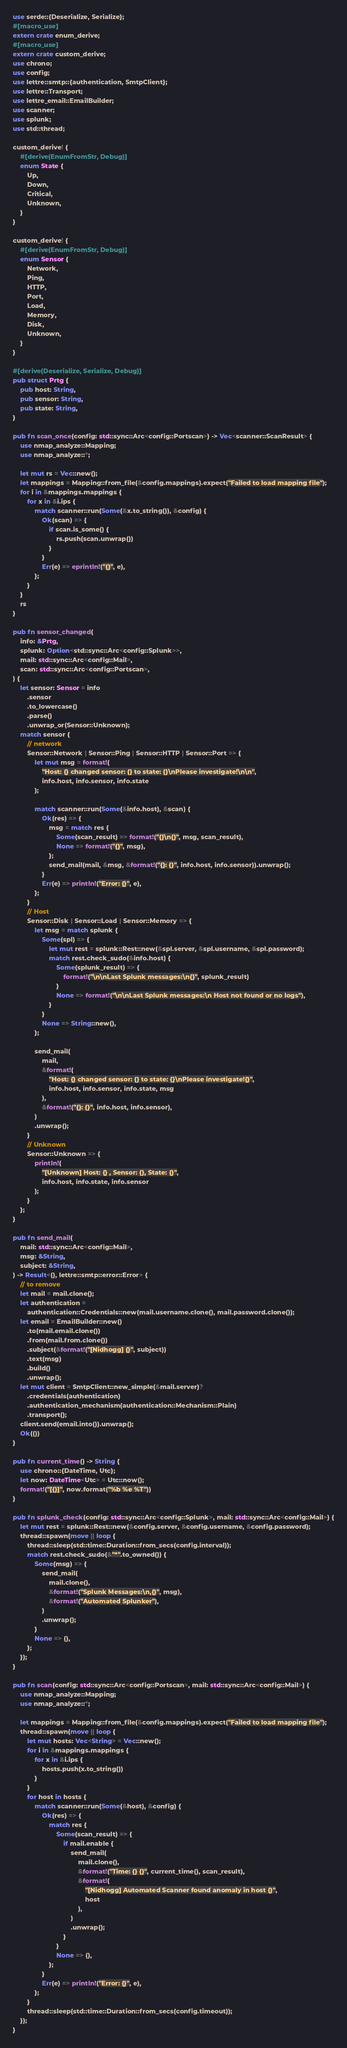<code> <loc_0><loc_0><loc_500><loc_500><_Rust_>use serde::{Deserialize, Serialize};
#[macro_use]
extern crate enum_derive;
#[macro_use]
extern crate custom_derive;
use chrono;
use config;
use lettre::smtp::{authentication, SmtpClient};
use lettre::Transport;
use lettre_email::EmailBuilder;
use scanner;
use splunk;
use std::thread;

custom_derive! {
    #[derive(EnumFromStr, Debug)]
    enum State {
        Up,
        Down,
        Critical,
        Unknown,
    }
}

custom_derive! {
    #[derive(EnumFromStr, Debug)]
    enum Sensor {
        Network,
        Ping,
        HTTP,
        Port,
        Load,
        Memory,
        Disk,
        Unknown,
    }
}

#[derive(Deserialize, Serialize, Debug)]
pub struct Prtg {
    pub host: String,
    pub sensor: String,
    pub state: String,
}

pub fn scan_once(config: std::sync::Arc<config::Portscan>) -> Vec<scanner::ScanResult> {
    use nmap_analyze::Mapping;
    use nmap_analyze::*;

    let mut rs = Vec::new();
    let mappings = Mapping::from_file(&config.mappings).expect("Failed to load mapping file");
    for i in &mappings.mappings {
        for x in &i.ips {
            match scanner::run(Some(&x.to_string()), &config) {
                Ok(scan) => {
                    if scan.is_some() {
                        rs.push(scan.unwrap())
                    }
                }
                Err(e) => eprintln!("{}", e),
            };
        }
    }
    rs
}

pub fn sensor_changed(
    info: &Prtg,
    splunk: Option<std::sync::Arc<config::Splunk>>,
    mail: std::sync::Arc<config::Mail>,
    scan: std::sync::Arc<config::Portscan>,
) {
    let sensor: Sensor = info
        .sensor
        .to_lowercase()
        .parse()
        .unwrap_or(Sensor::Unknown);
    match sensor {
        // network
        Sensor::Network | Sensor::Ping | Sensor::HTTP | Sensor::Port => {
            let mut msg = format!(
                "Host: {} changed sensor: {} to state: {}\nPlease investigate!\n\n",
                info.host, info.sensor, info.state
            );

            match scanner::run(Some(&info.host), &scan) {
                Ok(res) => {
                    msg = match res {
                        Some(scan_result) => format!("{}\n{}", msg, scan_result),
                        None => format!("{}", msg),
                    };
                    send_mail(mail, &msg, &format!("{}: {}", info.host, info.sensor)).unwrap();
                }
                Err(e) => println!("Error: {}", e),
            };
        }
        // Host
        Sensor::Disk | Sensor::Load | Sensor::Memory => {
            let msg = match splunk {
                Some(spl) => {
                    let mut rest = splunk::Rest::new(&spl.server, &spl.username, &spl.password);
                    match rest.check_sudo(&info.host) {
                        Some(splunk_result) => {
                            format!("\n\nLast Splunk messages:\n{}", splunk_result)
                        }
                        None => format!("\n\nLast Splunk messages:\n Host not found or no logs"),
                    }
                }
                None => String::new(),
            };

            send_mail(
                mail,
                &format!(
                    "Host: {} changed sensor: {} to state: {}\nPlease investigate!{}",
                    info.host, info.sensor, info.state, msg
                ),
                &format!("{}: {}", info.host, info.sensor),
            )
            .unwrap();
        }
        // Unknown
        Sensor::Unknown => {
            println!(
                "[Unknown] Host: {} , Sensor: {}, State: {}",
                info.host, info.state, info.sensor
            );
        }
    };
}

pub fn send_mail(
    mail: std::sync::Arc<config::Mail>,
    msg: &String,
    subject: &String,
) -> Result<(), lettre::smtp::error::Error> {
    // to remove
    let mail = mail.clone();
    let authentication =
        authentication::Credentials::new(mail.username.clone(), mail.password.clone());
    let email = EmailBuilder::new()
        .to(mail.email.clone())
        .from(mail.from.clone())
        .subject(&format!("[Nidhogg] {}", subject))
        .text(msg)
        .build()
        .unwrap();
    let mut client = SmtpClient::new_simple(&mail.server)?
        .credentials(authentication)
        .authentication_mechanism(authentication::Mechanism::Plain)
        .transport();
    client.send(email.into()).unwrap();
    Ok(())
}

pub fn current_time() -> String {
    use chrono::{DateTime, Utc};
    let now: DateTime<Utc> = Utc::now();
    format!("[{}]", now.format("%b %e %T"))
}

pub fn splunk_check(config: std::sync::Arc<config::Splunk>, mail: std::sync::Arc<config::Mail>) {
    let mut rest = splunk::Rest::new(&config.server, &config.username, &config.password);
    thread::spawn(move || loop {
        thread::sleep(std::time::Duration::from_secs(config.interval));
        match rest.check_sudo(&"*".to_owned()) {
            Some(msg) => {
                send_mail(
                    mail.clone(),
                    &format!("Splunk Messages:\n,{}", msg),
                    &format!("Automated Splunker"),
                )
                .unwrap();
            }
            None => (),
        };
    });
}

pub fn scan(config: std::sync::Arc<config::Portscan>, mail: std::sync::Arc<config::Mail>) {
    use nmap_analyze::Mapping;
    use nmap_analyze::*;

    let mappings = Mapping::from_file(&config.mappings).expect("Failed to load mapping file");
    thread::spawn(move || loop {
        let mut hosts: Vec<String> = Vec::new();
        for i in &mappings.mappings {
            for x in &i.ips {
                hosts.push(x.to_string())
            }
        }
        for host in hosts {
            match scanner::run(Some(&host), &config) {
                Ok(res) => {
                    match res {
                        Some(scan_result) => {
                            if mail.enable {
                                send_mail(
                                    mail.clone(),
                                    &format!("Time: {} {}", current_time(), scan_result),
                                    &format!(
                                        "[Nidhogg] Automated Scanner found anomaly in host {}",
                                        host
                                    ),
                                )
                                .unwrap();
                            }
                        }
                        None => (),
                    };
                }
                Err(e) => println!("Error: {}", e),
            };
        }
        thread::sleep(std::time::Duration::from_secs(config.timeout));
    });
}
</code> 